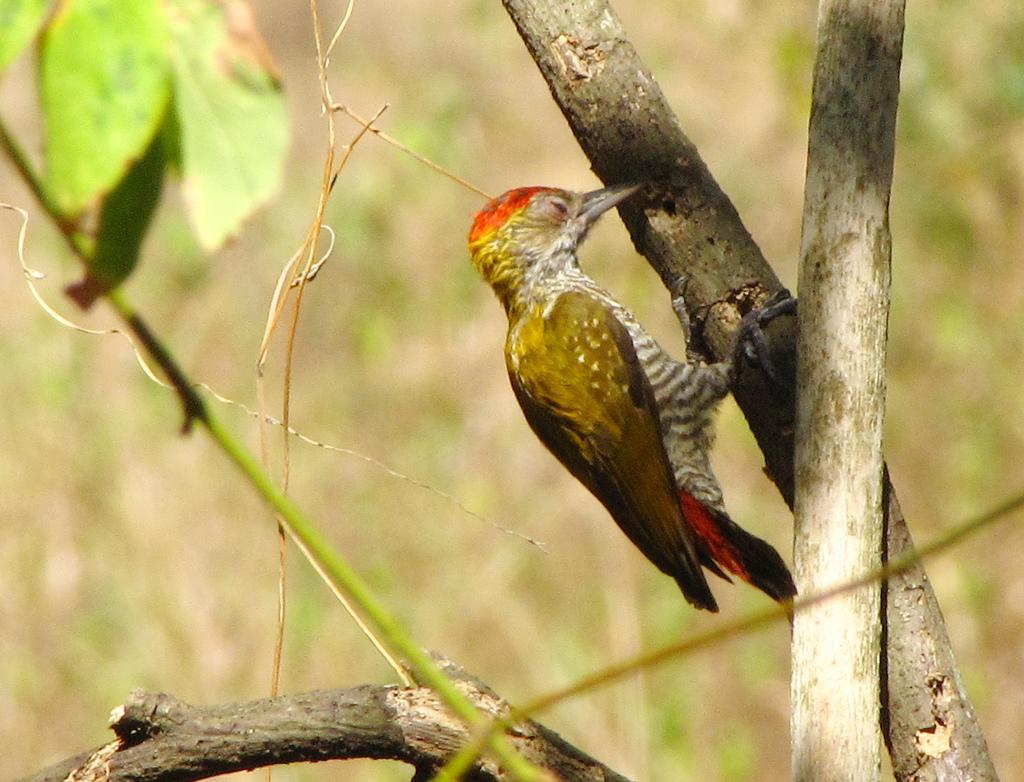What is the main subject in the center of the image? There is a bird on a tree in the center of the image. What can be seen in the background of the image? There are leaves visible in the background of the image. What type of locket can be seen hanging from the bird's neck in the image? There is no locket present on the bird's neck in the image. What is the visibility level due to in the image? The image does not depict any fog or reduced visibility; it is clear. How many cars are visible in the image? There are no cars present in the image. 